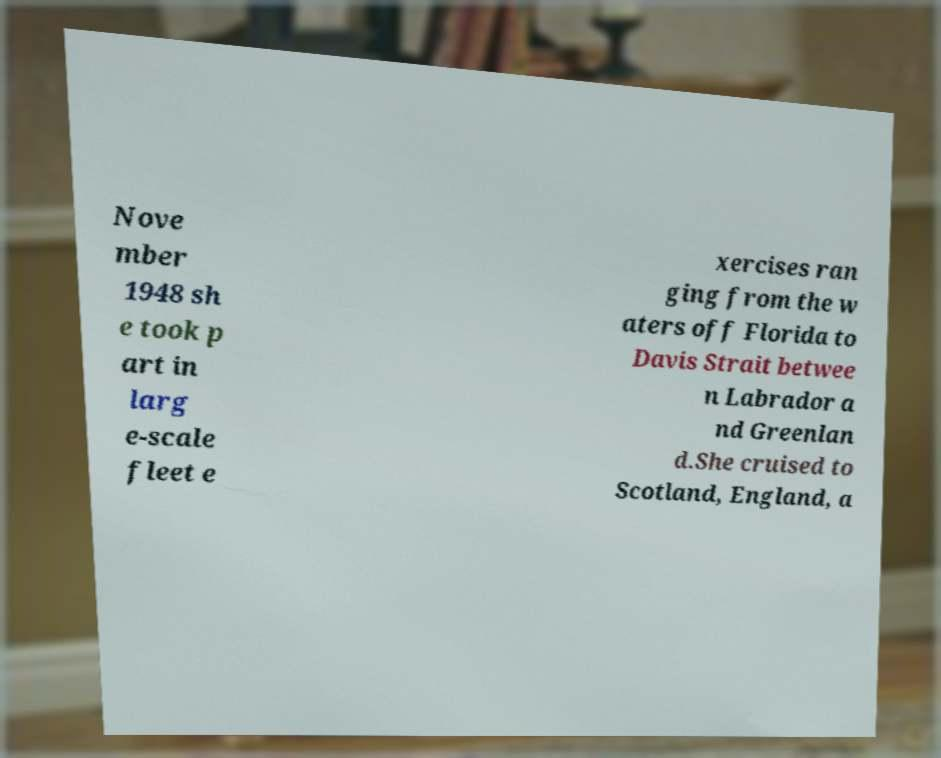There's text embedded in this image that I need extracted. Can you transcribe it verbatim? Nove mber 1948 sh e took p art in larg e-scale fleet e xercises ran ging from the w aters off Florida to Davis Strait betwee n Labrador a nd Greenlan d.She cruised to Scotland, England, a 